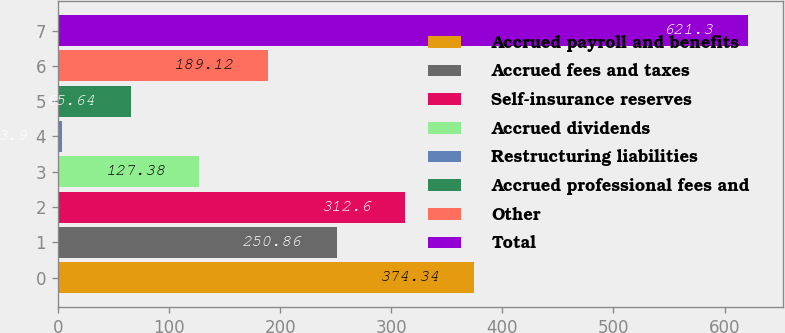<chart> <loc_0><loc_0><loc_500><loc_500><bar_chart><fcel>Accrued payroll and benefits<fcel>Accrued fees and taxes<fcel>Self-insurance reserves<fcel>Accrued dividends<fcel>Restructuring liabilities<fcel>Accrued professional fees and<fcel>Other<fcel>Total<nl><fcel>374.34<fcel>250.86<fcel>312.6<fcel>127.38<fcel>3.9<fcel>65.64<fcel>189.12<fcel>621.3<nl></chart> 